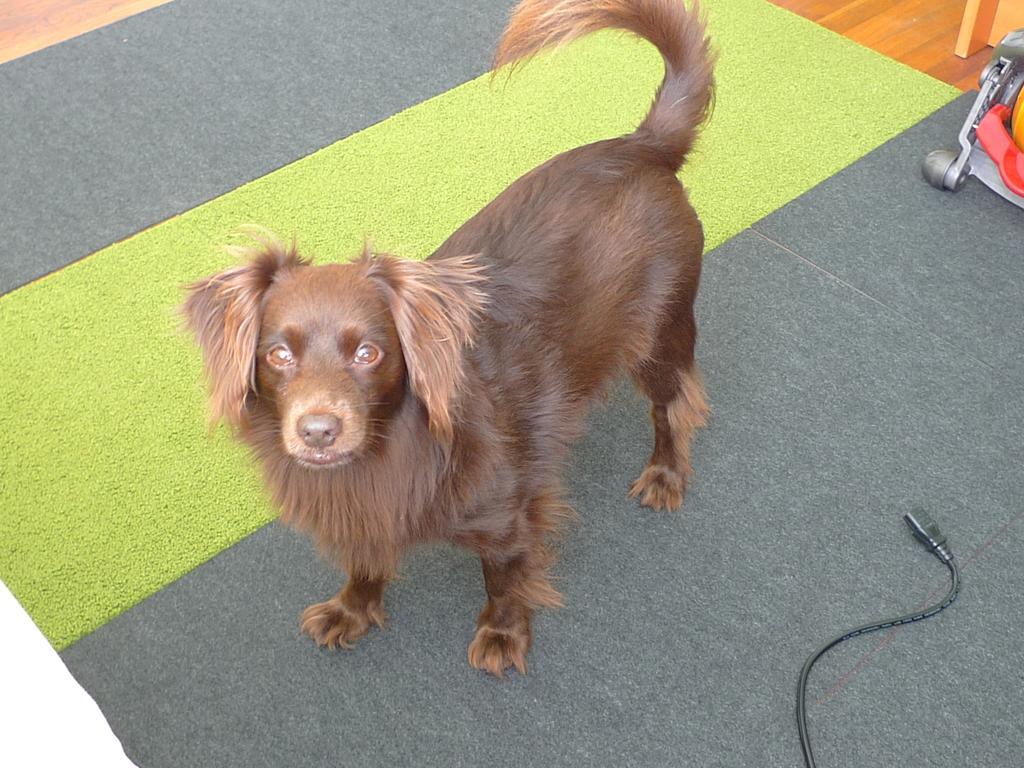Can you describe this image briefly? In this picture we can see the dog standing on the floor, side we can see wire. 